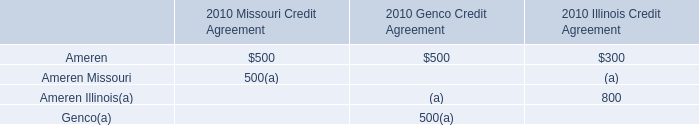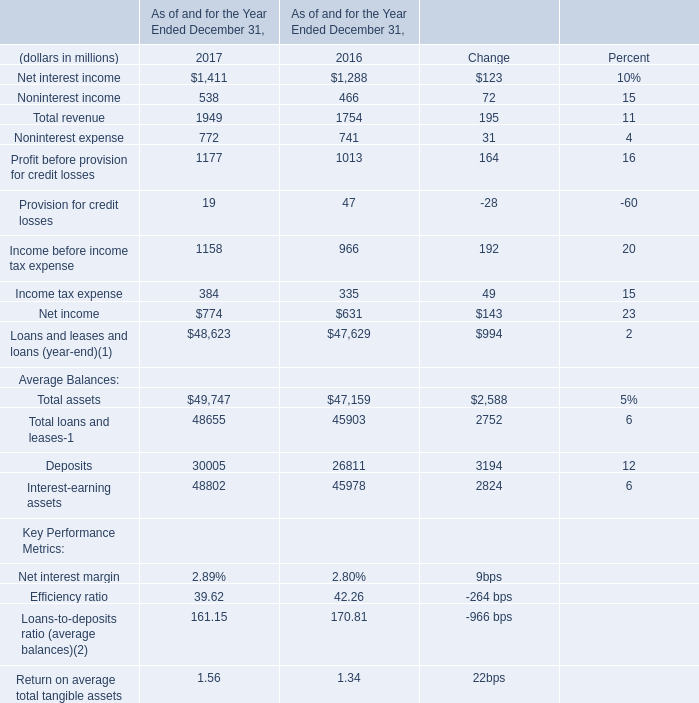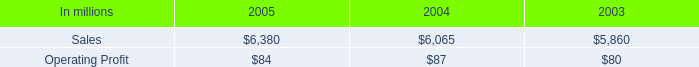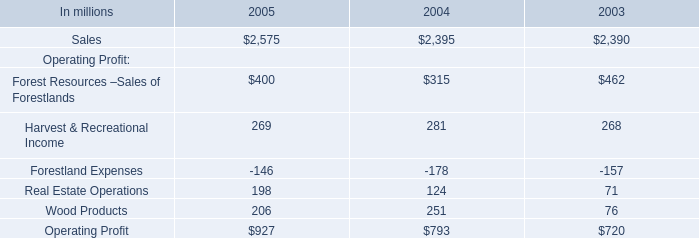Does Net interest income keeps increasing each year between 2016 and 2017? 
Answer: yes. 